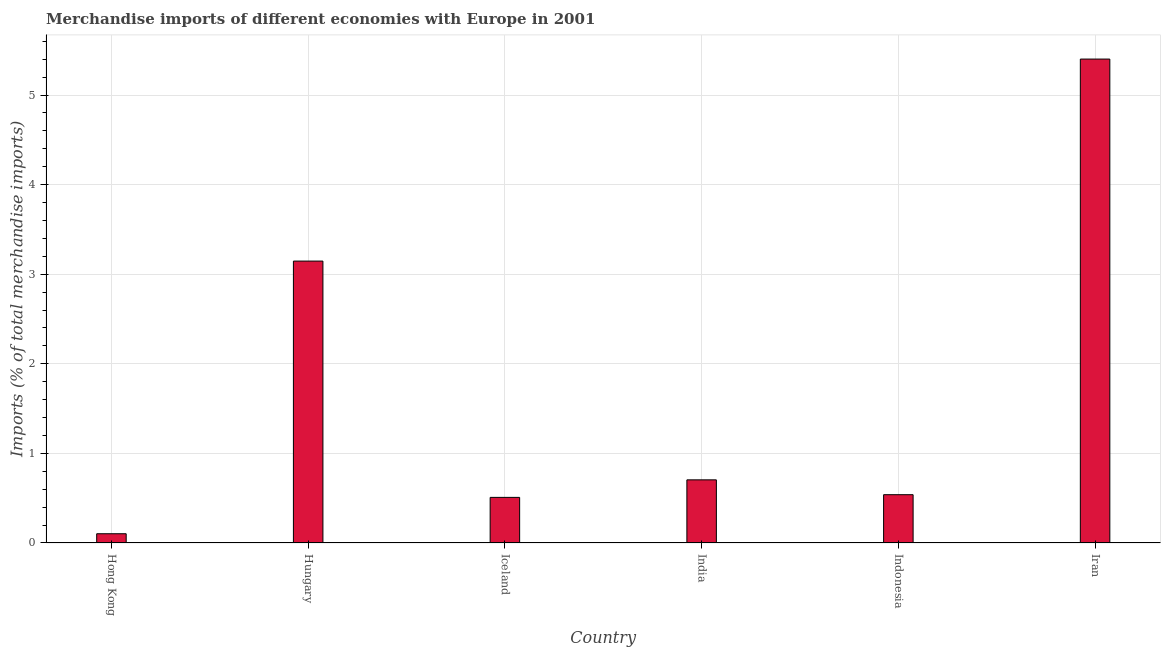Does the graph contain any zero values?
Give a very brief answer. No. Does the graph contain grids?
Provide a short and direct response. Yes. What is the title of the graph?
Give a very brief answer. Merchandise imports of different economies with Europe in 2001. What is the label or title of the Y-axis?
Give a very brief answer. Imports (% of total merchandise imports). What is the merchandise imports in Indonesia?
Your response must be concise. 0.54. Across all countries, what is the maximum merchandise imports?
Give a very brief answer. 5.4. Across all countries, what is the minimum merchandise imports?
Provide a succinct answer. 0.1. In which country was the merchandise imports maximum?
Your answer should be very brief. Iran. In which country was the merchandise imports minimum?
Your answer should be very brief. Hong Kong. What is the sum of the merchandise imports?
Offer a very short reply. 10.4. What is the difference between the merchandise imports in India and Indonesia?
Your response must be concise. 0.17. What is the average merchandise imports per country?
Offer a very short reply. 1.73. What is the median merchandise imports?
Keep it short and to the point. 0.62. What is the ratio of the merchandise imports in Hong Kong to that in Iceland?
Offer a terse response. 0.2. Is the difference between the merchandise imports in Iceland and India greater than the difference between any two countries?
Your answer should be very brief. No. What is the difference between the highest and the second highest merchandise imports?
Your answer should be compact. 2.25. Is the sum of the merchandise imports in Hong Kong and Hungary greater than the maximum merchandise imports across all countries?
Ensure brevity in your answer.  No. What is the difference between two consecutive major ticks on the Y-axis?
Ensure brevity in your answer.  1. What is the Imports (% of total merchandise imports) of Hong Kong?
Ensure brevity in your answer.  0.1. What is the Imports (% of total merchandise imports) of Hungary?
Provide a short and direct response. 3.15. What is the Imports (% of total merchandise imports) in Iceland?
Provide a succinct answer. 0.51. What is the Imports (% of total merchandise imports) of India?
Your answer should be very brief. 0.7. What is the Imports (% of total merchandise imports) of Indonesia?
Your response must be concise. 0.54. What is the Imports (% of total merchandise imports) in Iran?
Offer a terse response. 5.4. What is the difference between the Imports (% of total merchandise imports) in Hong Kong and Hungary?
Make the answer very short. -3.04. What is the difference between the Imports (% of total merchandise imports) in Hong Kong and Iceland?
Your response must be concise. -0.41. What is the difference between the Imports (% of total merchandise imports) in Hong Kong and India?
Provide a succinct answer. -0.6. What is the difference between the Imports (% of total merchandise imports) in Hong Kong and Indonesia?
Keep it short and to the point. -0.44. What is the difference between the Imports (% of total merchandise imports) in Hong Kong and Iran?
Provide a succinct answer. -5.3. What is the difference between the Imports (% of total merchandise imports) in Hungary and Iceland?
Provide a succinct answer. 2.64. What is the difference between the Imports (% of total merchandise imports) in Hungary and India?
Your answer should be very brief. 2.44. What is the difference between the Imports (% of total merchandise imports) in Hungary and Indonesia?
Make the answer very short. 2.61. What is the difference between the Imports (% of total merchandise imports) in Hungary and Iran?
Make the answer very short. -2.25. What is the difference between the Imports (% of total merchandise imports) in Iceland and India?
Give a very brief answer. -0.2. What is the difference between the Imports (% of total merchandise imports) in Iceland and Indonesia?
Provide a succinct answer. -0.03. What is the difference between the Imports (% of total merchandise imports) in Iceland and Iran?
Make the answer very short. -4.89. What is the difference between the Imports (% of total merchandise imports) in India and Indonesia?
Offer a terse response. 0.17. What is the difference between the Imports (% of total merchandise imports) in India and Iran?
Provide a succinct answer. -4.7. What is the difference between the Imports (% of total merchandise imports) in Indonesia and Iran?
Give a very brief answer. -4.86. What is the ratio of the Imports (% of total merchandise imports) in Hong Kong to that in Hungary?
Ensure brevity in your answer.  0.03. What is the ratio of the Imports (% of total merchandise imports) in Hong Kong to that in Iceland?
Your response must be concise. 0.2. What is the ratio of the Imports (% of total merchandise imports) in Hong Kong to that in India?
Ensure brevity in your answer.  0.15. What is the ratio of the Imports (% of total merchandise imports) in Hong Kong to that in Indonesia?
Offer a terse response. 0.19. What is the ratio of the Imports (% of total merchandise imports) in Hong Kong to that in Iran?
Offer a very short reply. 0.02. What is the ratio of the Imports (% of total merchandise imports) in Hungary to that in Iceland?
Keep it short and to the point. 6.18. What is the ratio of the Imports (% of total merchandise imports) in Hungary to that in India?
Offer a very short reply. 4.46. What is the ratio of the Imports (% of total merchandise imports) in Hungary to that in Indonesia?
Your answer should be very brief. 5.84. What is the ratio of the Imports (% of total merchandise imports) in Hungary to that in Iran?
Your response must be concise. 0.58. What is the ratio of the Imports (% of total merchandise imports) in Iceland to that in India?
Provide a succinct answer. 0.72. What is the ratio of the Imports (% of total merchandise imports) in Iceland to that in Indonesia?
Provide a short and direct response. 0.94. What is the ratio of the Imports (% of total merchandise imports) in Iceland to that in Iran?
Offer a very short reply. 0.09. What is the ratio of the Imports (% of total merchandise imports) in India to that in Indonesia?
Keep it short and to the point. 1.31. What is the ratio of the Imports (% of total merchandise imports) in India to that in Iran?
Provide a short and direct response. 0.13. 